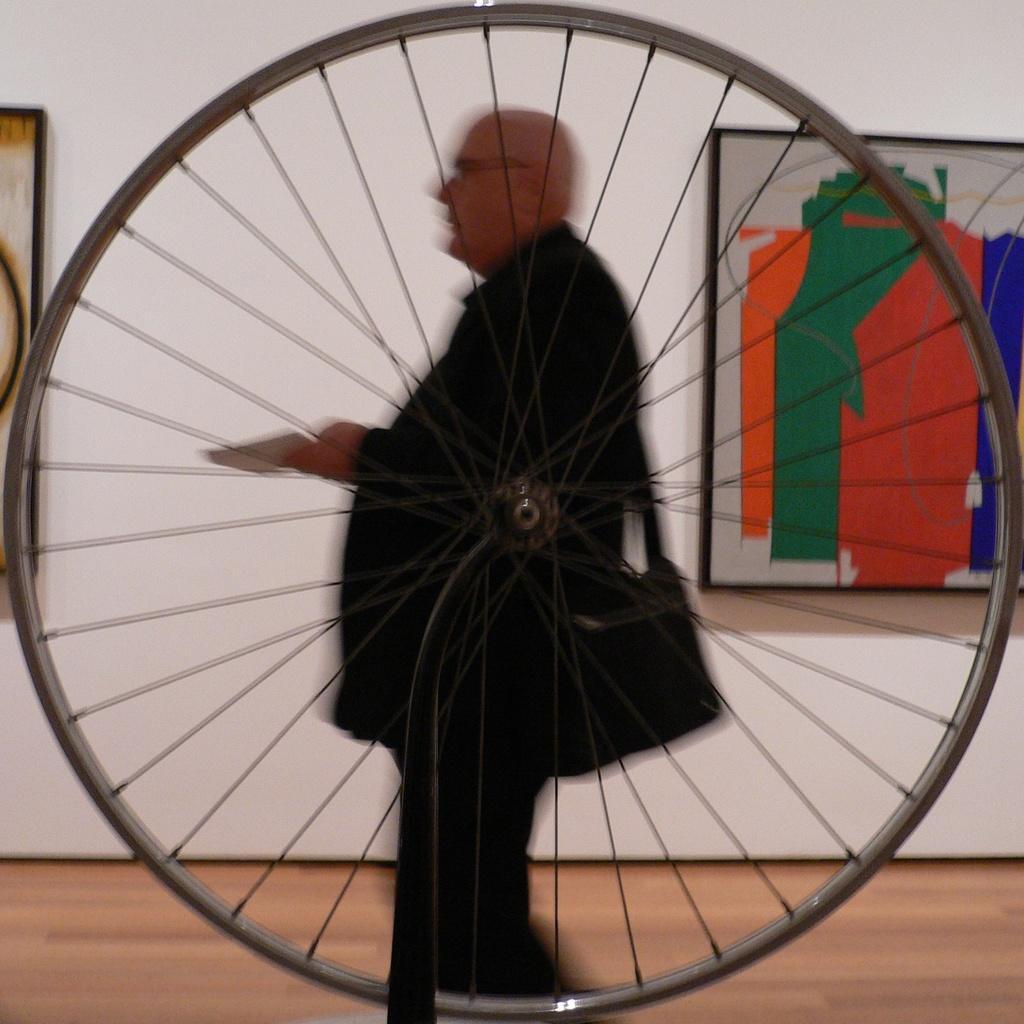Can you describe this image briefly? In this image, we can see a cycle rim, in the background there is a person standing and there is a white color wall. 